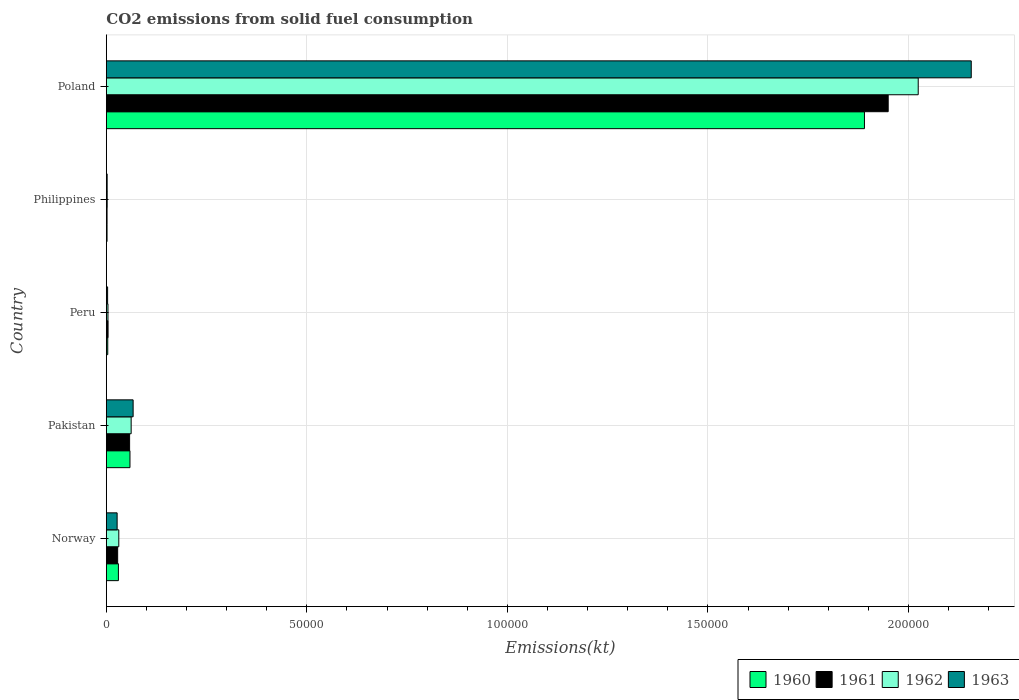Are the number of bars per tick equal to the number of legend labels?
Give a very brief answer. Yes. Are the number of bars on each tick of the Y-axis equal?
Your answer should be compact. Yes. In how many cases, is the number of bars for a given country not equal to the number of legend labels?
Make the answer very short. 0. What is the amount of CO2 emitted in 1961 in Poland?
Your answer should be very brief. 1.95e+05. Across all countries, what is the maximum amount of CO2 emitted in 1960?
Offer a very short reply. 1.89e+05. Across all countries, what is the minimum amount of CO2 emitted in 1963?
Your answer should be very brief. 201.69. In which country was the amount of CO2 emitted in 1960 maximum?
Ensure brevity in your answer.  Poland. In which country was the amount of CO2 emitted in 1961 minimum?
Make the answer very short. Philippines. What is the total amount of CO2 emitted in 1961 in the graph?
Provide a succinct answer. 2.04e+05. What is the difference between the amount of CO2 emitted in 1963 in Norway and that in Poland?
Give a very brief answer. -2.13e+05. What is the difference between the amount of CO2 emitted in 1962 in Norway and the amount of CO2 emitted in 1961 in Philippines?
Give a very brief answer. 2926.27. What is the average amount of CO2 emitted in 1961 per country?
Your answer should be very brief. 4.08e+04. What is the difference between the amount of CO2 emitted in 1962 and amount of CO2 emitted in 1963 in Pakistan?
Make the answer very short. -491.38. In how many countries, is the amount of CO2 emitted in 1960 greater than 30000 kt?
Make the answer very short. 1. What is the ratio of the amount of CO2 emitted in 1962 in Peru to that in Poland?
Provide a short and direct response. 0. Is the amount of CO2 emitted in 1960 in Philippines less than that in Poland?
Provide a succinct answer. Yes. Is the difference between the amount of CO2 emitted in 1962 in Norway and Peru greater than the difference between the amount of CO2 emitted in 1963 in Norway and Peru?
Ensure brevity in your answer.  Yes. What is the difference between the highest and the second highest amount of CO2 emitted in 1963?
Give a very brief answer. 2.09e+05. What is the difference between the highest and the lowest amount of CO2 emitted in 1961?
Your answer should be very brief. 1.95e+05. In how many countries, is the amount of CO2 emitted in 1961 greater than the average amount of CO2 emitted in 1961 taken over all countries?
Provide a short and direct response. 1. Is the sum of the amount of CO2 emitted in 1960 in Norway and Peru greater than the maximum amount of CO2 emitted in 1963 across all countries?
Make the answer very short. No. Is it the case that in every country, the sum of the amount of CO2 emitted in 1961 and amount of CO2 emitted in 1963 is greater than the amount of CO2 emitted in 1960?
Give a very brief answer. Yes. How many bars are there?
Your response must be concise. 20. What is the difference between two consecutive major ticks on the X-axis?
Make the answer very short. 5.00e+04. Does the graph contain any zero values?
Your answer should be very brief. No. Does the graph contain grids?
Provide a short and direct response. Yes. Where does the legend appear in the graph?
Your answer should be very brief. Bottom right. What is the title of the graph?
Ensure brevity in your answer.  CO2 emissions from solid fuel consumption. Does "1993" appear as one of the legend labels in the graph?
Offer a terse response. No. What is the label or title of the X-axis?
Give a very brief answer. Emissions(kt). What is the Emissions(kt) of 1960 in Norway?
Provide a succinct answer. 3010.61. What is the Emissions(kt) of 1961 in Norway?
Ensure brevity in your answer.  2823.59. What is the Emissions(kt) in 1962 in Norway?
Ensure brevity in your answer.  3105.95. What is the Emissions(kt) of 1963 in Norway?
Ensure brevity in your answer.  2691.58. What is the Emissions(kt) in 1960 in Pakistan?
Keep it short and to the point. 5892.87. What is the Emissions(kt) in 1961 in Pakistan?
Provide a short and direct response. 5804.86. What is the Emissions(kt) in 1962 in Pakistan?
Make the answer very short. 6189.9. What is the Emissions(kt) of 1963 in Pakistan?
Make the answer very short. 6681.27. What is the Emissions(kt) in 1960 in Peru?
Your answer should be compact. 352.03. What is the Emissions(kt) of 1961 in Peru?
Your answer should be compact. 432.71. What is the Emissions(kt) in 1962 in Peru?
Your answer should be compact. 407.04. What is the Emissions(kt) in 1963 in Peru?
Ensure brevity in your answer.  319.03. What is the Emissions(kt) in 1960 in Philippines?
Provide a succinct answer. 179.68. What is the Emissions(kt) of 1961 in Philippines?
Your answer should be very brief. 179.68. What is the Emissions(kt) of 1962 in Philippines?
Make the answer very short. 212.69. What is the Emissions(kt) of 1963 in Philippines?
Provide a succinct answer. 201.69. What is the Emissions(kt) of 1960 in Poland?
Provide a short and direct response. 1.89e+05. What is the Emissions(kt) in 1961 in Poland?
Offer a very short reply. 1.95e+05. What is the Emissions(kt) in 1962 in Poland?
Keep it short and to the point. 2.02e+05. What is the Emissions(kt) of 1963 in Poland?
Your answer should be very brief. 2.16e+05. Across all countries, what is the maximum Emissions(kt) of 1960?
Offer a terse response. 1.89e+05. Across all countries, what is the maximum Emissions(kt) of 1961?
Your answer should be compact. 1.95e+05. Across all countries, what is the maximum Emissions(kt) in 1962?
Keep it short and to the point. 2.02e+05. Across all countries, what is the maximum Emissions(kt) of 1963?
Offer a very short reply. 2.16e+05. Across all countries, what is the minimum Emissions(kt) in 1960?
Your answer should be compact. 179.68. Across all countries, what is the minimum Emissions(kt) of 1961?
Provide a short and direct response. 179.68. Across all countries, what is the minimum Emissions(kt) of 1962?
Keep it short and to the point. 212.69. Across all countries, what is the minimum Emissions(kt) of 1963?
Provide a succinct answer. 201.69. What is the total Emissions(kt) of 1960 in the graph?
Offer a very short reply. 1.98e+05. What is the total Emissions(kt) in 1961 in the graph?
Your answer should be very brief. 2.04e+05. What is the total Emissions(kt) of 1962 in the graph?
Keep it short and to the point. 2.12e+05. What is the total Emissions(kt) in 1963 in the graph?
Your answer should be compact. 2.26e+05. What is the difference between the Emissions(kt) in 1960 in Norway and that in Pakistan?
Provide a short and direct response. -2882.26. What is the difference between the Emissions(kt) of 1961 in Norway and that in Pakistan?
Keep it short and to the point. -2981.27. What is the difference between the Emissions(kt) of 1962 in Norway and that in Pakistan?
Provide a short and direct response. -3083.95. What is the difference between the Emissions(kt) of 1963 in Norway and that in Pakistan?
Your answer should be very brief. -3989.7. What is the difference between the Emissions(kt) in 1960 in Norway and that in Peru?
Offer a very short reply. 2658.57. What is the difference between the Emissions(kt) in 1961 in Norway and that in Peru?
Provide a succinct answer. 2390.88. What is the difference between the Emissions(kt) in 1962 in Norway and that in Peru?
Make the answer very short. 2698.91. What is the difference between the Emissions(kt) of 1963 in Norway and that in Peru?
Make the answer very short. 2372.55. What is the difference between the Emissions(kt) of 1960 in Norway and that in Philippines?
Your response must be concise. 2830.92. What is the difference between the Emissions(kt) in 1961 in Norway and that in Philippines?
Give a very brief answer. 2643.91. What is the difference between the Emissions(kt) in 1962 in Norway and that in Philippines?
Your answer should be compact. 2893.26. What is the difference between the Emissions(kt) of 1963 in Norway and that in Philippines?
Your response must be concise. 2489.89. What is the difference between the Emissions(kt) of 1960 in Norway and that in Poland?
Give a very brief answer. -1.86e+05. What is the difference between the Emissions(kt) in 1961 in Norway and that in Poland?
Offer a very short reply. -1.92e+05. What is the difference between the Emissions(kt) in 1962 in Norway and that in Poland?
Your response must be concise. -1.99e+05. What is the difference between the Emissions(kt) of 1963 in Norway and that in Poland?
Ensure brevity in your answer.  -2.13e+05. What is the difference between the Emissions(kt) of 1960 in Pakistan and that in Peru?
Your answer should be compact. 5540.84. What is the difference between the Emissions(kt) of 1961 in Pakistan and that in Peru?
Keep it short and to the point. 5372.15. What is the difference between the Emissions(kt) of 1962 in Pakistan and that in Peru?
Provide a short and direct response. 5782.86. What is the difference between the Emissions(kt) in 1963 in Pakistan and that in Peru?
Your response must be concise. 6362.24. What is the difference between the Emissions(kt) of 1960 in Pakistan and that in Philippines?
Make the answer very short. 5713.19. What is the difference between the Emissions(kt) in 1961 in Pakistan and that in Philippines?
Make the answer very short. 5625.18. What is the difference between the Emissions(kt) in 1962 in Pakistan and that in Philippines?
Offer a very short reply. 5977.21. What is the difference between the Emissions(kt) in 1963 in Pakistan and that in Philippines?
Ensure brevity in your answer.  6479.59. What is the difference between the Emissions(kt) of 1960 in Pakistan and that in Poland?
Keep it short and to the point. -1.83e+05. What is the difference between the Emissions(kt) of 1961 in Pakistan and that in Poland?
Provide a succinct answer. -1.89e+05. What is the difference between the Emissions(kt) in 1962 in Pakistan and that in Poland?
Your answer should be very brief. -1.96e+05. What is the difference between the Emissions(kt) of 1963 in Pakistan and that in Poland?
Provide a short and direct response. -2.09e+05. What is the difference between the Emissions(kt) in 1960 in Peru and that in Philippines?
Provide a short and direct response. 172.35. What is the difference between the Emissions(kt) in 1961 in Peru and that in Philippines?
Ensure brevity in your answer.  253.02. What is the difference between the Emissions(kt) of 1962 in Peru and that in Philippines?
Make the answer very short. 194.35. What is the difference between the Emissions(kt) in 1963 in Peru and that in Philippines?
Make the answer very short. 117.34. What is the difference between the Emissions(kt) in 1960 in Peru and that in Poland?
Make the answer very short. -1.89e+05. What is the difference between the Emissions(kt) in 1961 in Peru and that in Poland?
Ensure brevity in your answer.  -1.95e+05. What is the difference between the Emissions(kt) of 1962 in Peru and that in Poland?
Your answer should be very brief. -2.02e+05. What is the difference between the Emissions(kt) of 1963 in Peru and that in Poland?
Keep it short and to the point. -2.15e+05. What is the difference between the Emissions(kt) of 1960 in Philippines and that in Poland?
Keep it short and to the point. -1.89e+05. What is the difference between the Emissions(kt) in 1961 in Philippines and that in Poland?
Give a very brief answer. -1.95e+05. What is the difference between the Emissions(kt) in 1962 in Philippines and that in Poland?
Provide a short and direct response. -2.02e+05. What is the difference between the Emissions(kt) of 1963 in Philippines and that in Poland?
Your response must be concise. -2.15e+05. What is the difference between the Emissions(kt) in 1960 in Norway and the Emissions(kt) in 1961 in Pakistan?
Give a very brief answer. -2794.25. What is the difference between the Emissions(kt) of 1960 in Norway and the Emissions(kt) of 1962 in Pakistan?
Make the answer very short. -3179.29. What is the difference between the Emissions(kt) in 1960 in Norway and the Emissions(kt) in 1963 in Pakistan?
Your answer should be compact. -3670.67. What is the difference between the Emissions(kt) in 1961 in Norway and the Emissions(kt) in 1962 in Pakistan?
Offer a very short reply. -3366.31. What is the difference between the Emissions(kt) in 1961 in Norway and the Emissions(kt) in 1963 in Pakistan?
Your response must be concise. -3857.68. What is the difference between the Emissions(kt) in 1962 in Norway and the Emissions(kt) in 1963 in Pakistan?
Offer a very short reply. -3575.32. What is the difference between the Emissions(kt) in 1960 in Norway and the Emissions(kt) in 1961 in Peru?
Your answer should be compact. 2577.9. What is the difference between the Emissions(kt) in 1960 in Norway and the Emissions(kt) in 1962 in Peru?
Keep it short and to the point. 2603.57. What is the difference between the Emissions(kt) of 1960 in Norway and the Emissions(kt) of 1963 in Peru?
Ensure brevity in your answer.  2691.58. What is the difference between the Emissions(kt) in 1961 in Norway and the Emissions(kt) in 1962 in Peru?
Offer a very short reply. 2416.55. What is the difference between the Emissions(kt) in 1961 in Norway and the Emissions(kt) in 1963 in Peru?
Give a very brief answer. 2504.56. What is the difference between the Emissions(kt) in 1962 in Norway and the Emissions(kt) in 1963 in Peru?
Make the answer very short. 2786.92. What is the difference between the Emissions(kt) in 1960 in Norway and the Emissions(kt) in 1961 in Philippines?
Provide a succinct answer. 2830.92. What is the difference between the Emissions(kt) in 1960 in Norway and the Emissions(kt) in 1962 in Philippines?
Provide a succinct answer. 2797.92. What is the difference between the Emissions(kt) of 1960 in Norway and the Emissions(kt) of 1963 in Philippines?
Your answer should be compact. 2808.92. What is the difference between the Emissions(kt) in 1961 in Norway and the Emissions(kt) in 1962 in Philippines?
Keep it short and to the point. 2610.9. What is the difference between the Emissions(kt) in 1961 in Norway and the Emissions(kt) in 1963 in Philippines?
Ensure brevity in your answer.  2621.91. What is the difference between the Emissions(kt) of 1962 in Norway and the Emissions(kt) of 1963 in Philippines?
Your answer should be very brief. 2904.26. What is the difference between the Emissions(kt) of 1960 in Norway and the Emissions(kt) of 1961 in Poland?
Offer a very short reply. -1.92e+05. What is the difference between the Emissions(kt) of 1960 in Norway and the Emissions(kt) of 1962 in Poland?
Offer a very short reply. -1.99e+05. What is the difference between the Emissions(kt) in 1960 in Norway and the Emissions(kt) in 1963 in Poland?
Your response must be concise. -2.13e+05. What is the difference between the Emissions(kt) of 1961 in Norway and the Emissions(kt) of 1962 in Poland?
Make the answer very short. -2.00e+05. What is the difference between the Emissions(kt) in 1961 in Norway and the Emissions(kt) in 1963 in Poland?
Ensure brevity in your answer.  -2.13e+05. What is the difference between the Emissions(kt) of 1962 in Norway and the Emissions(kt) of 1963 in Poland?
Offer a very short reply. -2.13e+05. What is the difference between the Emissions(kt) of 1960 in Pakistan and the Emissions(kt) of 1961 in Peru?
Give a very brief answer. 5460.16. What is the difference between the Emissions(kt) of 1960 in Pakistan and the Emissions(kt) of 1962 in Peru?
Give a very brief answer. 5485.83. What is the difference between the Emissions(kt) in 1960 in Pakistan and the Emissions(kt) in 1963 in Peru?
Give a very brief answer. 5573.84. What is the difference between the Emissions(kt) in 1961 in Pakistan and the Emissions(kt) in 1962 in Peru?
Provide a succinct answer. 5397.82. What is the difference between the Emissions(kt) in 1961 in Pakistan and the Emissions(kt) in 1963 in Peru?
Make the answer very short. 5485.83. What is the difference between the Emissions(kt) of 1962 in Pakistan and the Emissions(kt) of 1963 in Peru?
Ensure brevity in your answer.  5870.87. What is the difference between the Emissions(kt) in 1960 in Pakistan and the Emissions(kt) in 1961 in Philippines?
Offer a terse response. 5713.19. What is the difference between the Emissions(kt) of 1960 in Pakistan and the Emissions(kt) of 1962 in Philippines?
Give a very brief answer. 5680.18. What is the difference between the Emissions(kt) of 1960 in Pakistan and the Emissions(kt) of 1963 in Philippines?
Make the answer very short. 5691.18. What is the difference between the Emissions(kt) in 1961 in Pakistan and the Emissions(kt) in 1962 in Philippines?
Keep it short and to the point. 5592.18. What is the difference between the Emissions(kt) in 1961 in Pakistan and the Emissions(kt) in 1963 in Philippines?
Your answer should be compact. 5603.18. What is the difference between the Emissions(kt) in 1962 in Pakistan and the Emissions(kt) in 1963 in Philippines?
Offer a terse response. 5988.21. What is the difference between the Emissions(kt) in 1960 in Pakistan and the Emissions(kt) in 1961 in Poland?
Provide a short and direct response. -1.89e+05. What is the difference between the Emissions(kt) of 1960 in Pakistan and the Emissions(kt) of 1962 in Poland?
Give a very brief answer. -1.97e+05. What is the difference between the Emissions(kt) in 1960 in Pakistan and the Emissions(kt) in 1963 in Poland?
Make the answer very short. -2.10e+05. What is the difference between the Emissions(kt) in 1961 in Pakistan and the Emissions(kt) in 1962 in Poland?
Your response must be concise. -1.97e+05. What is the difference between the Emissions(kt) in 1961 in Pakistan and the Emissions(kt) in 1963 in Poland?
Ensure brevity in your answer.  -2.10e+05. What is the difference between the Emissions(kt) of 1962 in Pakistan and the Emissions(kt) of 1963 in Poland?
Your answer should be compact. -2.09e+05. What is the difference between the Emissions(kt) of 1960 in Peru and the Emissions(kt) of 1961 in Philippines?
Offer a very short reply. 172.35. What is the difference between the Emissions(kt) of 1960 in Peru and the Emissions(kt) of 1962 in Philippines?
Your answer should be very brief. 139.35. What is the difference between the Emissions(kt) in 1960 in Peru and the Emissions(kt) in 1963 in Philippines?
Provide a succinct answer. 150.35. What is the difference between the Emissions(kt) of 1961 in Peru and the Emissions(kt) of 1962 in Philippines?
Your response must be concise. 220.02. What is the difference between the Emissions(kt) of 1961 in Peru and the Emissions(kt) of 1963 in Philippines?
Provide a succinct answer. 231.02. What is the difference between the Emissions(kt) of 1962 in Peru and the Emissions(kt) of 1963 in Philippines?
Make the answer very short. 205.35. What is the difference between the Emissions(kt) of 1960 in Peru and the Emissions(kt) of 1961 in Poland?
Ensure brevity in your answer.  -1.95e+05. What is the difference between the Emissions(kt) in 1960 in Peru and the Emissions(kt) in 1962 in Poland?
Ensure brevity in your answer.  -2.02e+05. What is the difference between the Emissions(kt) of 1960 in Peru and the Emissions(kt) of 1963 in Poland?
Give a very brief answer. -2.15e+05. What is the difference between the Emissions(kt) in 1961 in Peru and the Emissions(kt) in 1962 in Poland?
Provide a succinct answer. -2.02e+05. What is the difference between the Emissions(kt) of 1961 in Peru and the Emissions(kt) of 1963 in Poland?
Offer a very short reply. -2.15e+05. What is the difference between the Emissions(kt) of 1962 in Peru and the Emissions(kt) of 1963 in Poland?
Provide a succinct answer. -2.15e+05. What is the difference between the Emissions(kt) of 1960 in Philippines and the Emissions(kt) of 1961 in Poland?
Make the answer very short. -1.95e+05. What is the difference between the Emissions(kt) in 1960 in Philippines and the Emissions(kt) in 1962 in Poland?
Give a very brief answer. -2.02e+05. What is the difference between the Emissions(kt) of 1960 in Philippines and the Emissions(kt) of 1963 in Poland?
Ensure brevity in your answer.  -2.15e+05. What is the difference between the Emissions(kt) in 1961 in Philippines and the Emissions(kt) in 1962 in Poland?
Your answer should be very brief. -2.02e+05. What is the difference between the Emissions(kt) in 1961 in Philippines and the Emissions(kt) in 1963 in Poland?
Offer a very short reply. -2.15e+05. What is the difference between the Emissions(kt) in 1962 in Philippines and the Emissions(kt) in 1963 in Poland?
Your answer should be very brief. -2.15e+05. What is the average Emissions(kt) of 1960 per country?
Keep it short and to the point. 3.97e+04. What is the average Emissions(kt) of 1961 per country?
Your answer should be compact. 4.08e+04. What is the average Emissions(kt) of 1962 per country?
Your response must be concise. 4.25e+04. What is the average Emissions(kt) in 1963 per country?
Your answer should be compact. 4.51e+04. What is the difference between the Emissions(kt) of 1960 and Emissions(kt) of 1961 in Norway?
Keep it short and to the point. 187.02. What is the difference between the Emissions(kt) of 1960 and Emissions(kt) of 1962 in Norway?
Your answer should be very brief. -95.34. What is the difference between the Emissions(kt) of 1960 and Emissions(kt) of 1963 in Norway?
Ensure brevity in your answer.  319.03. What is the difference between the Emissions(kt) in 1961 and Emissions(kt) in 1962 in Norway?
Provide a short and direct response. -282.36. What is the difference between the Emissions(kt) in 1961 and Emissions(kt) in 1963 in Norway?
Your response must be concise. 132.01. What is the difference between the Emissions(kt) of 1962 and Emissions(kt) of 1963 in Norway?
Offer a terse response. 414.37. What is the difference between the Emissions(kt) of 1960 and Emissions(kt) of 1961 in Pakistan?
Provide a short and direct response. 88.01. What is the difference between the Emissions(kt) in 1960 and Emissions(kt) in 1962 in Pakistan?
Offer a very short reply. -297.03. What is the difference between the Emissions(kt) in 1960 and Emissions(kt) in 1963 in Pakistan?
Give a very brief answer. -788.4. What is the difference between the Emissions(kt) of 1961 and Emissions(kt) of 1962 in Pakistan?
Ensure brevity in your answer.  -385.04. What is the difference between the Emissions(kt) of 1961 and Emissions(kt) of 1963 in Pakistan?
Ensure brevity in your answer.  -876.41. What is the difference between the Emissions(kt) of 1962 and Emissions(kt) of 1963 in Pakistan?
Your response must be concise. -491.38. What is the difference between the Emissions(kt) of 1960 and Emissions(kt) of 1961 in Peru?
Your answer should be compact. -80.67. What is the difference between the Emissions(kt) of 1960 and Emissions(kt) of 1962 in Peru?
Your answer should be very brief. -55.01. What is the difference between the Emissions(kt) in 1960 and Emissions(kt) in 1963 in Peru?
Offer a terse response. 33. What is the difference between the Emissions(kt) of 1961 and Emissions(kt) of 1962 in Peru?
Offer a very short reply. 25.67. What is the difference between the Emissions(kt) of 1961 and Emissions(kt) of 1963 in Peru?
Offer a terse response. 113.68. What is the difference between the Emissions(kt) of 1962 and Emissions(kt) of 1963 in Peru?
Offer a terse response. 88.01. What is the difference between the Emissions(kt) of 1960 and Emissions(kt) of 1962 in Philippines?
Offer a terse response. -33. What is the difference between the Emissions(kt) of 1960 and Emissions(kt) of 1963 in Philippines?
Give a very brief answer. -22. What is the difference between the Emissions(kt) in 1961 and Emissions(kt) in 1962 in Philippines?
Offer a very short reply. -33. What is the difference between the Emissions(kt) of 1961 and Emissions(kt) of 1963 in Philippines?
Provide a short and direct response. -22. What is the difference between the Emissions(kt) of 1962 and Emissions(kt) of 1963 in Philippines?
Your answer should be compact. 11. What is the difference between the Emissions(kt) of 1960 and Emissions(kt) of 1961 in Poland?
Your response must be concise. -5918.54. What is the difference between the Emissions(kt) in 1960 and Emissions(kt) in 1962 in Poland?
Ensure brevity in your answer.  -1.34e+04. What is the difference between the Emissions(kt) in 1960 and Emissions(kt) in 1963 in Poland?
Offer a terse response. -2.66e+04. What is the difference between the Emissions(kt) in 1961 and Emissions(kt) in 1962 in Poland?
Keep it short and to the point. -7484.35. What is the difference between the Emissions(kt) in 1961 and Emissions(kt) in 1963 in Poland?
Provide a succinct answer. -2.07e+04. What is the difference between the Emissions(kt) in 1962 and Emissions(kt) in 1963 in Poland?
Keep it short and to the point. -1.32e+04. What is the ratio of the Emissions(kt) of 1960 in Norway to that in Pakistan?
Your response must be concise. 0.51. What is the ratio of the Emissions(kt) in 1961 in Norway to that in Pakistan?
Your answer should be compact. 0.49. What is the ratio of the Emissions(kt) in 1962 in Norway to that in Pakistan?
Provide a short and direct response. 0.5. What is the ratio of the Emissions(kt) of 1963 in Norway to that in Pakistan?
Your answer should be very brief. 0.4. What is the ratio of the Emissions(kt) in 1960 in Norway to that in Peru?
Provide a succinct answer. 8.55. What is the ratio of the Emissions(kt) of 1961 in Norway to that in Peru?
Make the answer very short. 6.53. What is the ratio of the Emissions(kt) in 1962 in Norway to that in Peru?
Keep it short and to the point. 7.63. What is the ratio of the Emissions(kt) in 1963 in Norway to that in Peru?
Offer a very short reply. 8.44. What is the ratio of the Emissions(kt) of 1960 in Norway to that in Philippines?
Make the answer very short. 16.76. What is the ratio of the Emissions(kt) of 1961 in Norway to that in Philippines?
Give a very brief answer. 15.71. What is the ratio of the Emissions(kt) in 1962 in Norway to that in Philippines?
Offer a very short reply. 14.6. What is the ratio of the Emissions(kt) of 1963 in Norway to that in Philippines?
Offer a very short reply. 13.35. What is the ratio of the Emissions(kt) of 1960 in Norway to that in Poland?
Ensure brevity in your answer.  0.02. What is the ratio of the Emissions(kt) of 1961 in Norway to that in Poland?
Your answer should be compact. 0.01. What is the ratio of the Emissions(kt) of 1962 in Norway to that in Poland?
Your answer should be compact. 0.02. What is the ratio of the Emissions(kt) in 1963 in Norway to that in Poland?
Give a very brief answer. 0.01. What is the ratio of the Emissions(kt) in 1960 in Pakistan to that in Peru?
Offer a terse response. 16.74. What is the ratio of the Emissions(kt) of 1961 in Pakistan to that in Peru?
Provide a short and direct response. 13.42. What is the ratio of the Emissions(kt) in 1962 in Pakistan to that in Peru?
Provide a succinct answer. 15.21. What is the ratio of the Emissions(kt) in 1963 in Pakistan to that in Peru?
Offer a very short reply. 20.94. What is the ratio of the Emissions(kt) in 1960 in Pakistan to that in Philippines?
Your answer should be very brief. 32.8. What is the ratio of the Emissions(kt) of 1961 in Pakistan to that in Philippines?
Your answer should be compact. 32.31. What is the ratio of the Emissions(kt) in 1962 in Pakistan to that in Philippines?
Keep it short and to the point. 29.1. What is the ratio of the Emissions(kt) of 1963 in Pakistan to that in Philippines?
Make the answer very short. 33.13. What is the ratio of the Emissions(kt) of 1960 in Pakistan to that in Poland?
Provide a short and direct response. 0.03. What is the ratio of the Emissions(kt) in 1961 in Pakistan to that in Poland?
Keep it short and to the point. 0.03. What is the ratio of the Emissions(kt) of 1962 in Pakistan to that in Poland?
Make the answer very short. 0.03. What is the ratio of the Emissions(kt) of 1963 in Pakistan to that in Poland?
Offer a terse response. 0.03. What is the ratio of the Emissions(kt) in 1960 in Peru to that in Philippines?
Keep it short and to the point. 1.96. What is the ratio of the Emissions(kt) of 1961 in Peru to that in Philippines?
Provide a short and direct response. 2.41. What is the ratio of the Emissions(kt) of 1962 in Peru to that in Philippines?
Offer a terse response. 1.91. What is the ratio of the Emissions(kt) in 1963 in Peru to that in Philippines?
Make the answer very short. 1.58. What is the ratio of the Emissions(kt) of 1960 in Peru to that in Poland?
Keep it short and to the point. 0. What is the ratio of the Emissions(kt) in 1961 in Peru to that in Poland?
Keep it short and to the point. 0. What is the ratio of the Emissions(kt) in 1962 in Peru to that in Poland?
Provide a short and direct response. 0. What is the ratio of the Emissions(kt) in 1963 in Peru to that in Poland?
Your answer should be very brief. 0. What is the ratio of the Emissions(kt) in 1960 in Philippines to that in Poland?
Offer a terse response. 0. What is the ratio of the Emissions(kt) in 1961 in Philippines to that in Poland?
Provide a short and direct response. 0. What is the ratio of the Emissions(kt) in 1962 in Philippines to that in Poland?
Your answer should be very brief. 0. What is the ratio of the Emissions(kt) of 1963 in Philippines to that in Poland?
Your answer should be compact. 0. What is the difference between the highest and the second highest Emissions(kt) of 1960?
Offer a terse response. 1.83e+05. What is the difference between the highest and the second highest Emissions(kt) in 1961?
Offer a terse response. 1.89e+05. What is the difference between the highest and the second highest Emissions(kt) in 1962?
Provide a short and direct response. 1.96e+05. What is the difference between the highest and the second highest Emissions(kt) in 1963?
Offer a very short reply. 2.09e+05. What is the difference between the highest and the lowest Emissions(kt) in 1960?
Keep it short and to the point. 1.89e+05. What is the difference between the highest and the lowest Emissions(kt) of 1961?
Provide a succinct answer. 1.95e+05. What is the difference between the highest and the lowest Emissions(kt) in 1962?
Your answer should be compact. 2.02e+05. What is the difference between the highest and the lowest Emissions(kt) in 1963?
Provide a short and direct response. 2.15e+05. 